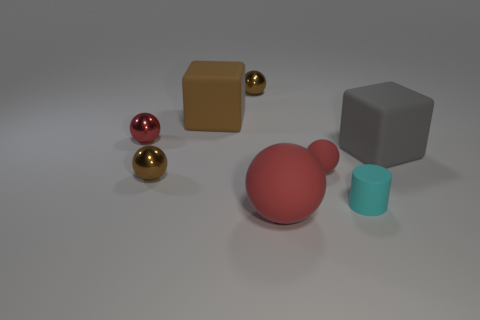How many red spheres must be subtracted to get 1 red spheres? 2 Subtract all rubber spheres. How many spheres are left? 3 Subtract 4 spheres. How many spheres are left? 1 Subtract all brown balls. How many yellow cylinders are left? 0 Subtract all red spheres. How many spheres are left? 2 Subtract all spheres. How many objects are left? 3 Subtract all green blocks. Subtract all green cylinders. How many blocks are left? 2 Subtract all small green spheres. Subtract all large spheres. How many objects are left? 7 Add 8 cyan rubber objects. How many cyan rubber objects are left? 9 Add 3 big things. How many big things exist? 6 